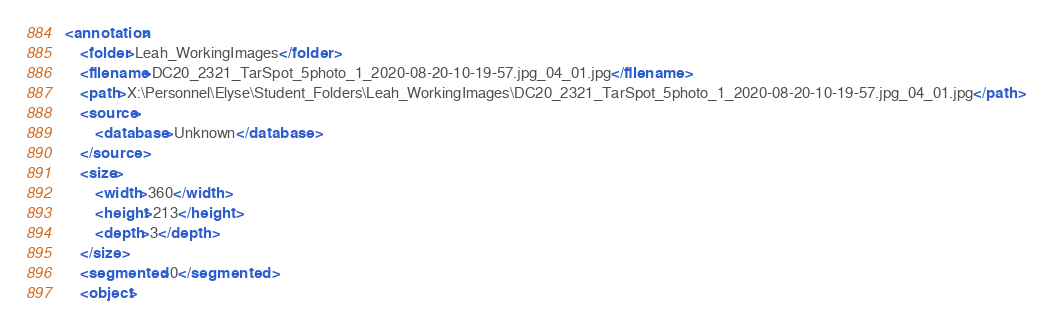Convert code to text. <code><loc_0><loc_0><loc_500><loc_500><_XML_><annotation>
	<folder>Leah_WorkingImages</folder>
	<filename>DC20_2321_TarSpot_5photo_1_2020-08-20-10-19-57.jpg_04_01.jpg</filename>
	<path>X:\Personnel\Elyse\Student_Folders\Leah_WorkingImages\DC20_2321_TarSpot_5photo_1_2020-08-20-10-19-57.jpg_04_01.jpg</path>
	<source>
		<database>Unknown</database>
	</source>
	<size>
		<width>360</width>
		<height>213</height>
		<depth>3</depth>
	</size>
	<segmented>0</segmented>
	<object></code> 